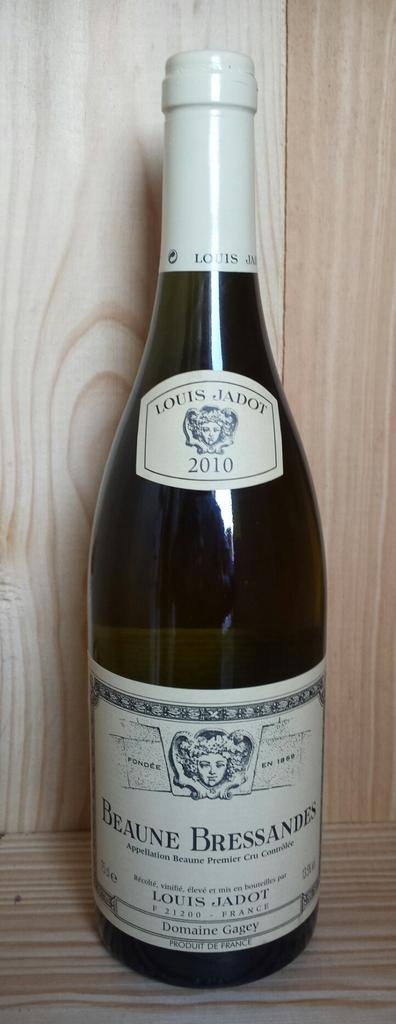<image>
Present a compact description of the photo's key features. A bottle of Beaune Bressandes sitting in a cabinet 